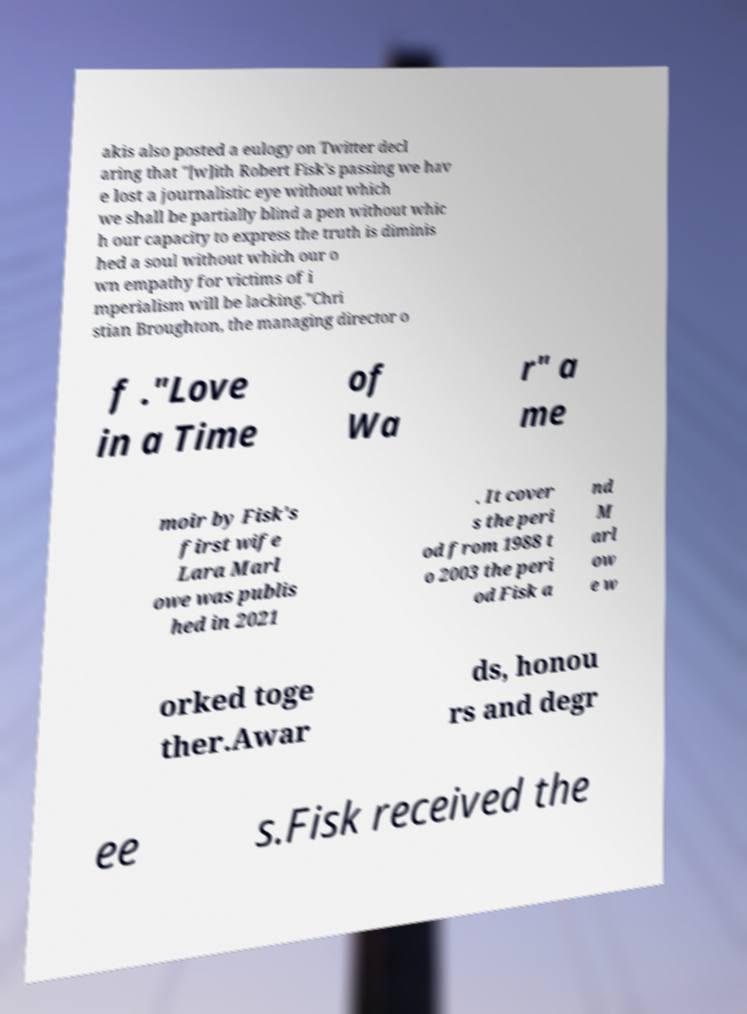What messages or text are displayed in this image? I need them in a readable, typed format. akis also posted a eulogy on Twitter decl aring that "[w]ith Robert Fisk's passing we hav e lost a journalistic eye without which we shall be partially blind a pen without whic h our capacity to express the truth is diminis hed a soul without which our o wn empathy for victims of i mperialism will be lacking."Chri stian Broughton, the managing director o f ."Love in a Time of Wa r" a me moir by Fisk's first wife Lara Marl owe was publis hed in 2021 . It cover s the peri od from 1988 t o 2003 the peri od Fisk a nd M arl ow e w orked toge ther.Awar ds, honou rs and degr ee s.Fisk received the 